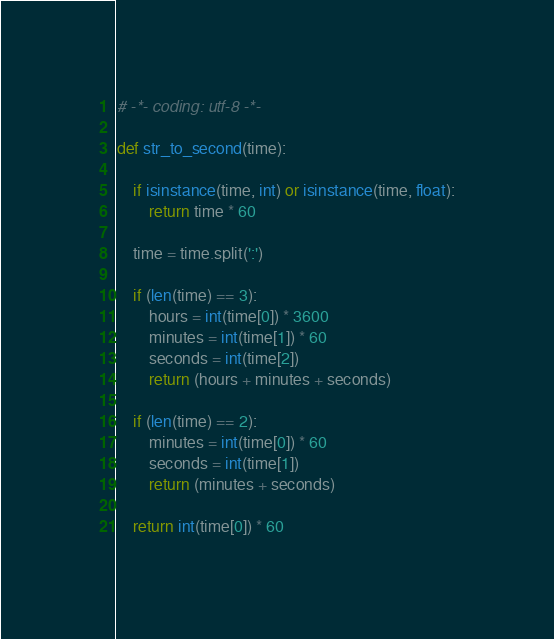<code> <loc_0><loc_0><loc_500><loc_500><_Python_># -*- coding: utf-8 -*-

def str_to_second(time):

	if isinstance(time, int) or isinstance(time, float):
		return time * 60

	time = time.split(':')

	if (len(time) == 3):
		hours = int(time[0]) * 3600
		minutes = int(time[1]) * 60
		seconds = int(time[2])
		return (hours + minutes + seconds)	

	if (len(time) == 2):
		minutes = int(time[0]) * 60
		seconds = int(time[1])
		return (minutes + seconds)	

	return int(time[0]) * 60</code> 